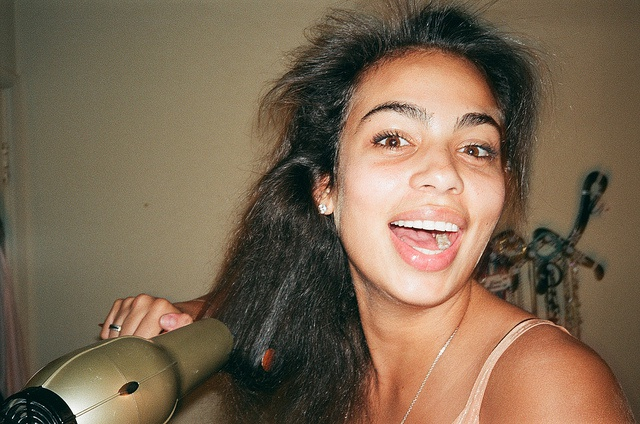Describe the objects in this image and their specific colors. I can see people in darkgreen, black, tan, and salmon tones and hair drier in black, olive, gray, and tan tones in this image. 